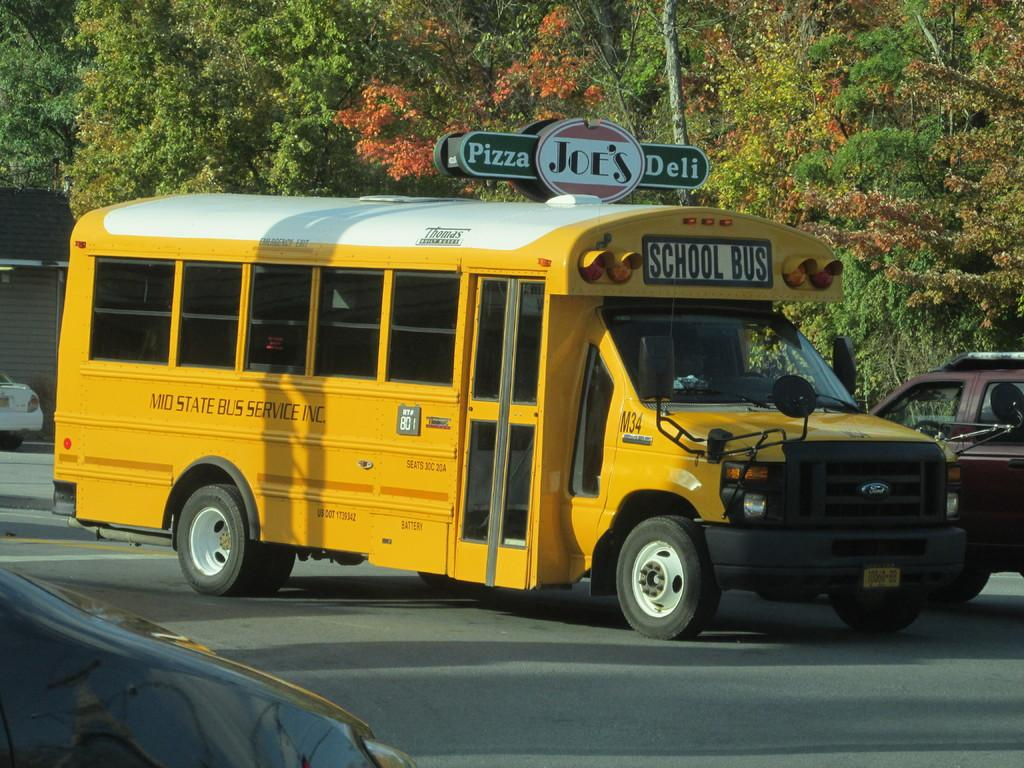<image>
Create a compact narrative representing the image presented. A school bus drives past Joe's Deli, where one can get pizza. 